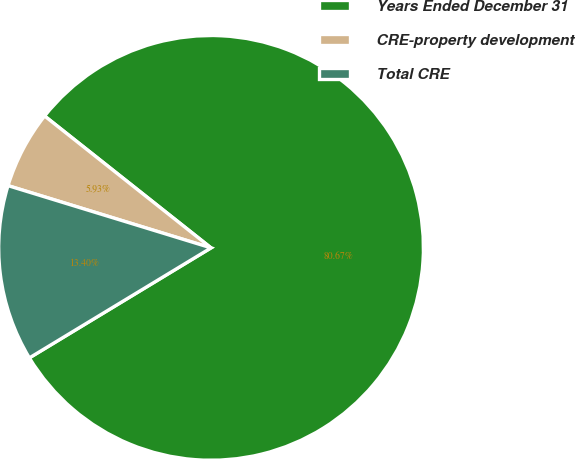Convert chart to OTSL. <chart><loc_0><loc_0><loc_500><loc_500><pie_chart><fcel>Years Ended December 31<fcel>CRE-property development<fcel>Total CRE<nl><fcel>80.67%<fcel>5.93%<fcel>13.4%<nl></chart> 